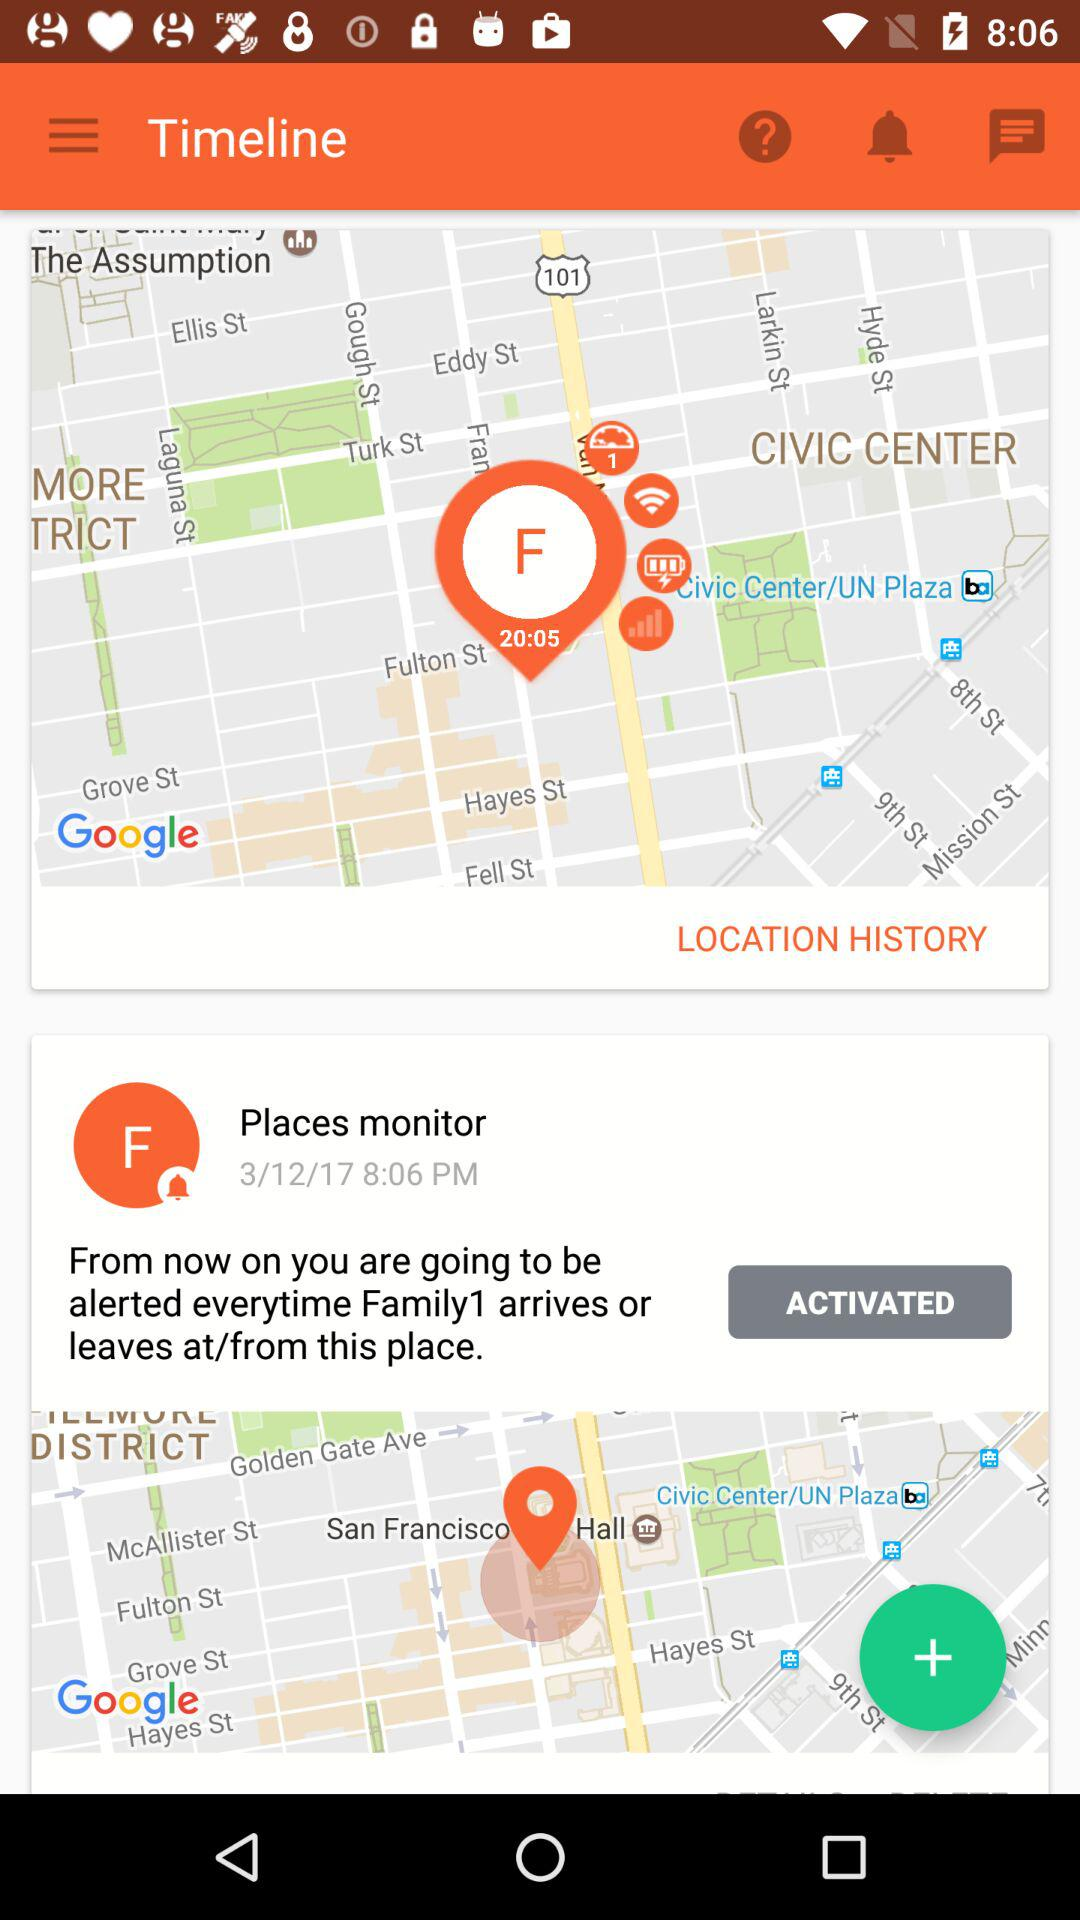How many maps are on the screen?
Answer the question using a single word or phrase. 2 